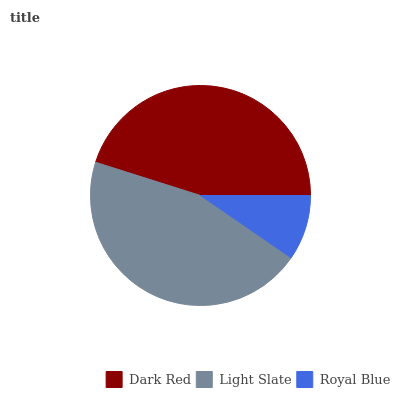Is Royal Blue the minimum?
Answer yes or no. Yes. Is Light Slate the maximum?
Answer yes or no. Yes. Is Light Slate the minimum?
Answer yes or no. No. Is Royal Blue the maximum?
Answer yes or no. No. Is Light Slate greater than Royal Blue?
Answer yes or no. Yes. Is Royal Blue less than Light Slate?
Answer yes or no. Yes. Is Royal Blue greater than Light Slate?
Answer yes or no. No. Is Light Slate less than Royal Blue?
Answer yes or no. No. Is Dark Red the high median?
Answer yes or no. Yes. Is Dark Red the low median?
Answer yes or no. Yes. Is Light Slate the high median?
Answer yes or no. No. Is Light Slate the low median?
Answer yes or no. No. 